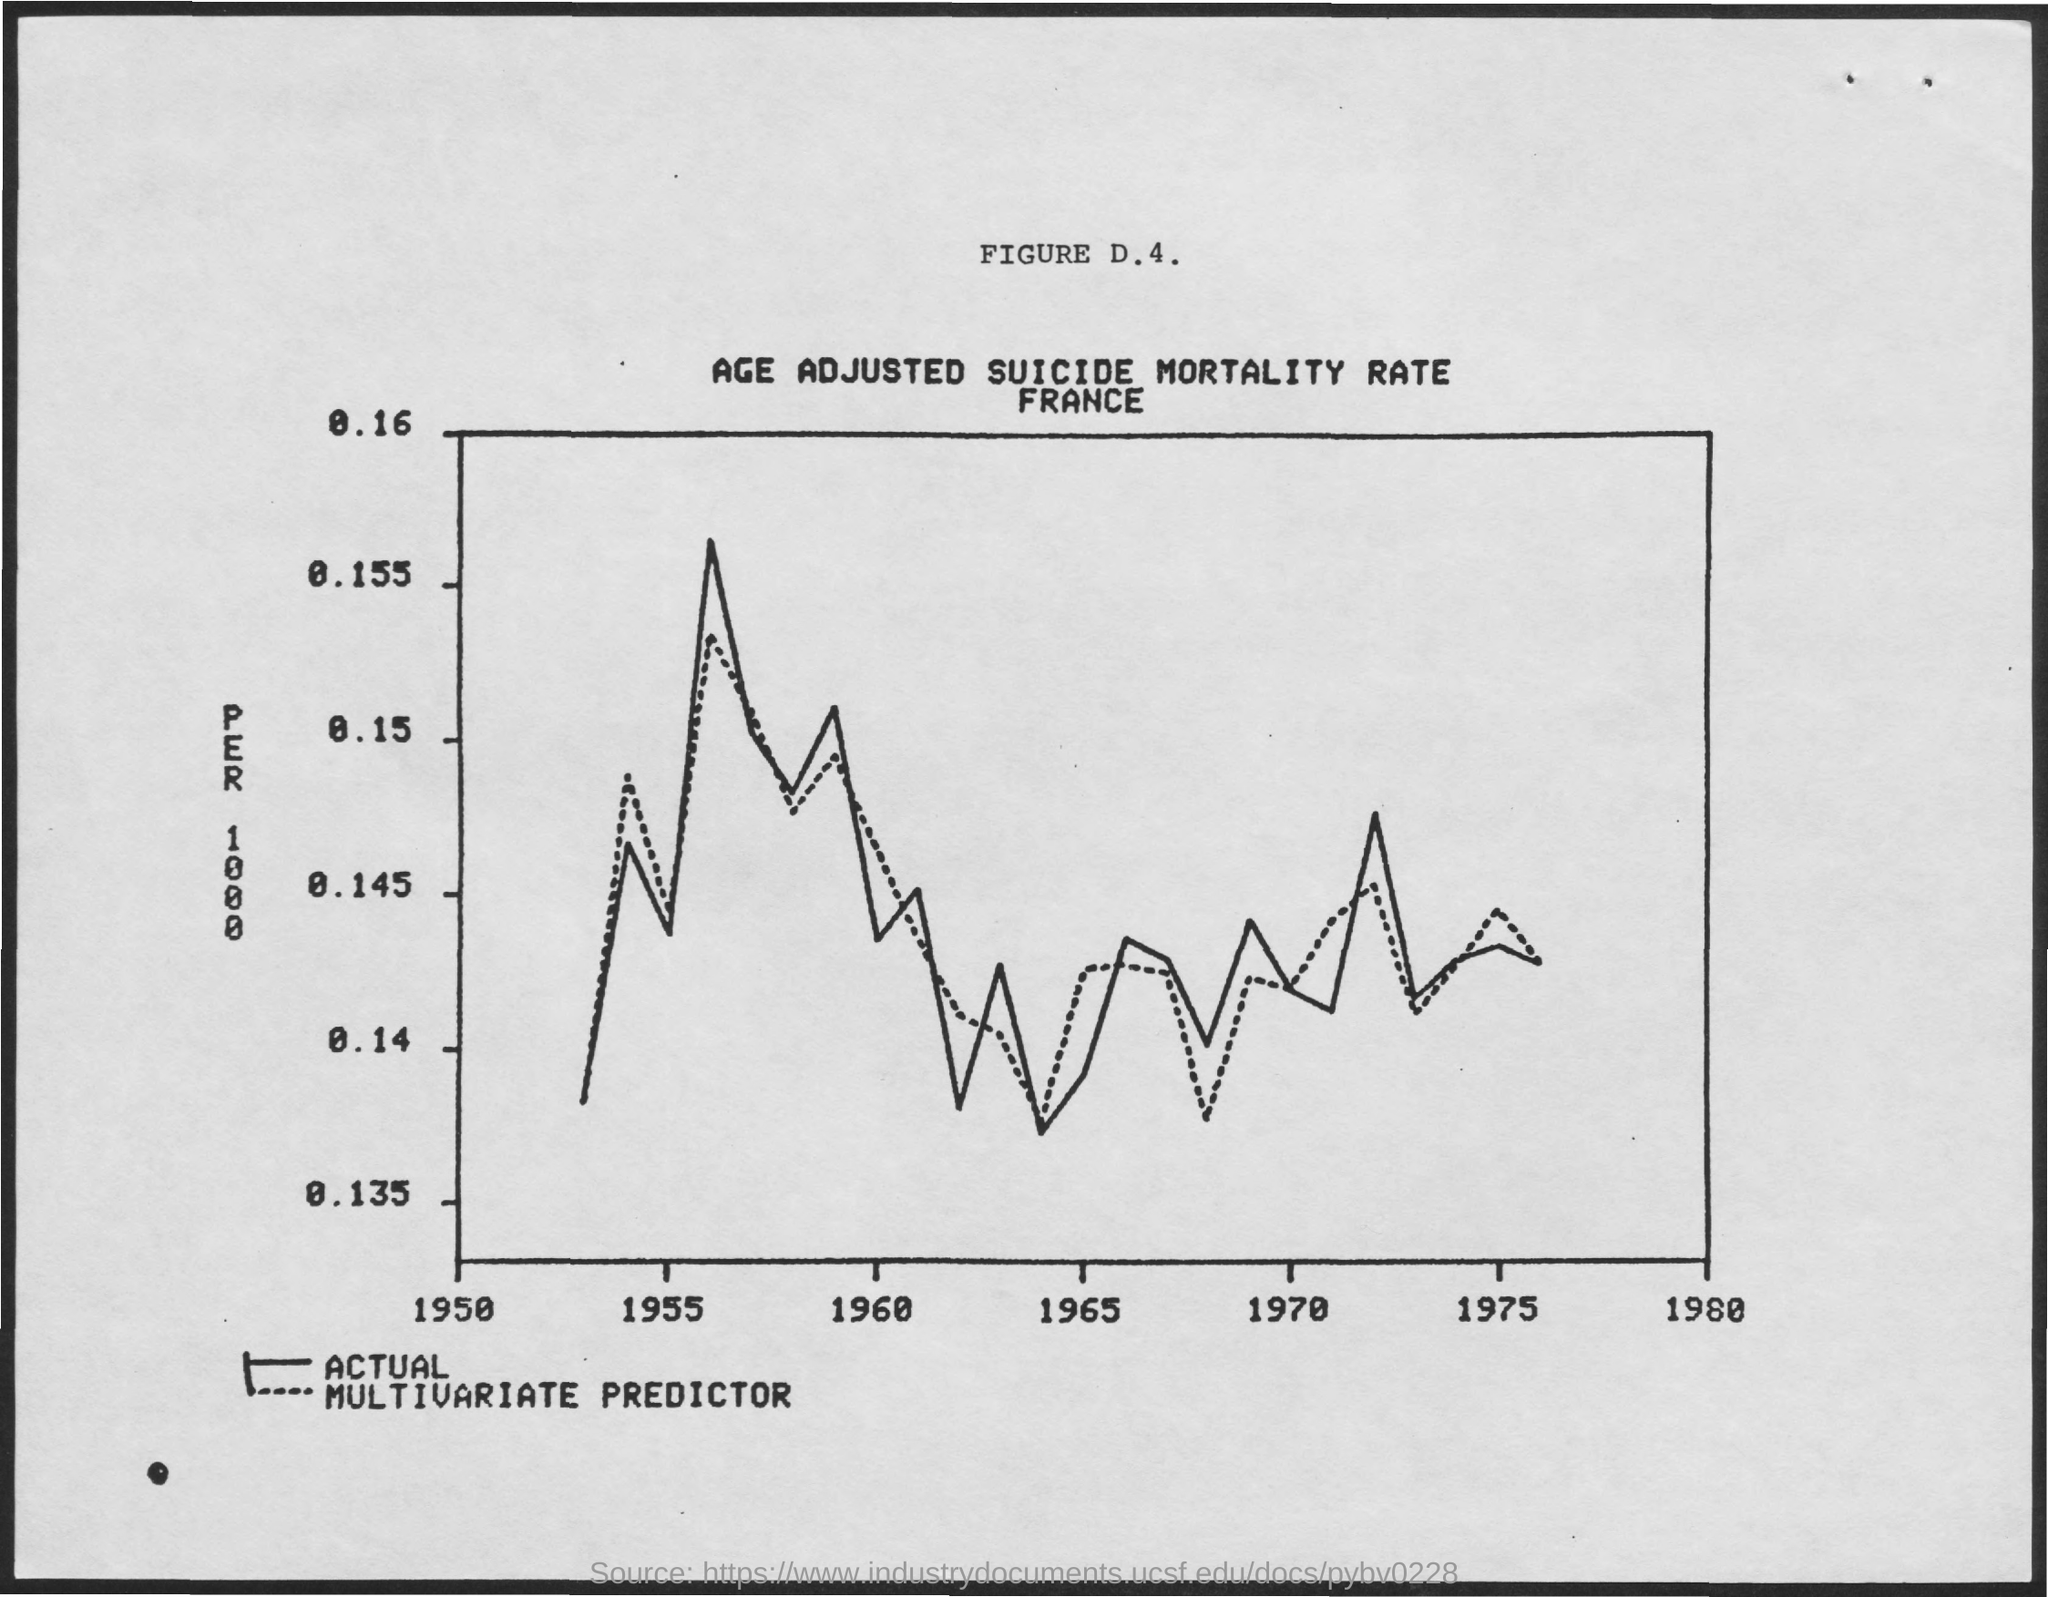What is the title for the figure d.4
Offer a terse response. Age adjusted suicide mortality rate france. What is mentioned on the y-axis side
Offer a terse response. PER 1000. What does those  dotted curve in the graph represent ?
Keep it short and to the point. MULTIVARIATE PREDICTOR. 